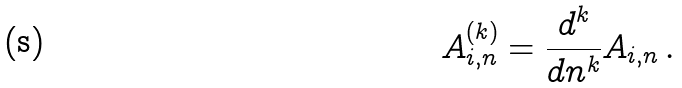Convert formula to latex. <formula><loc_0><loc_0><loc_500><loc_500>A ^ { ( k ) } _ { i , n } = \frac { d ^ { k } } { d n ^ { k } } A _ { i , n } \, .</formula> 